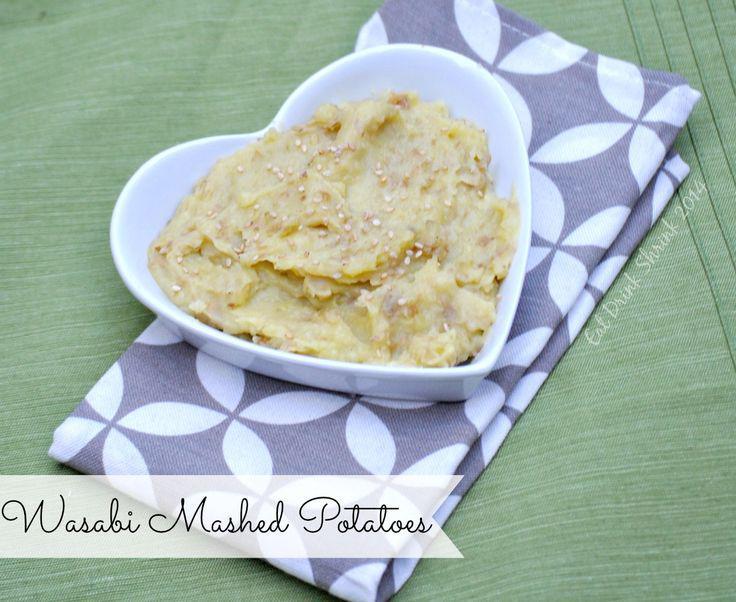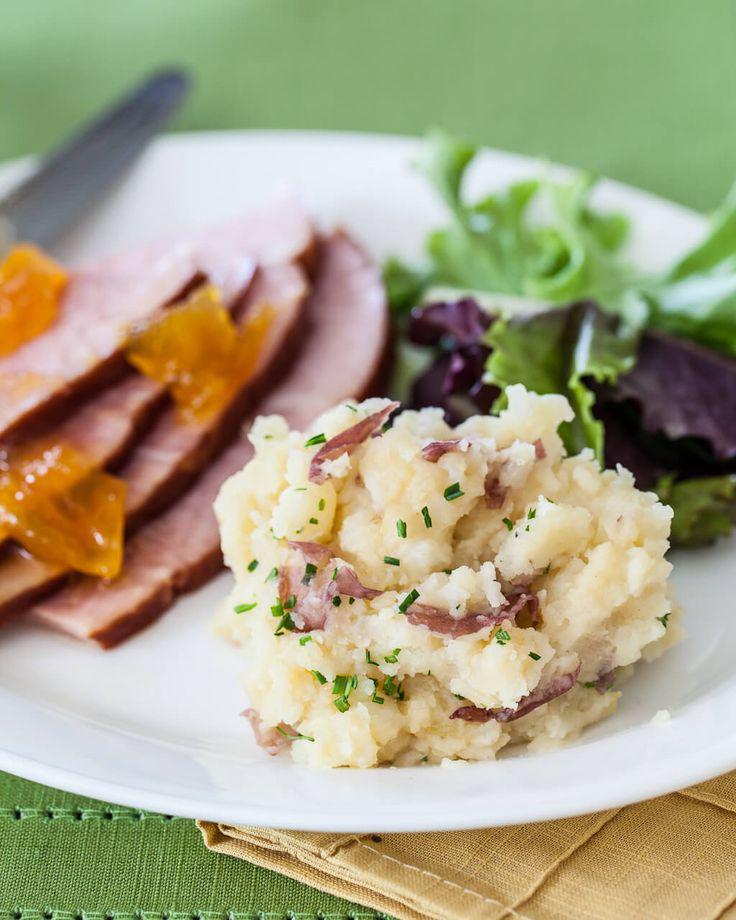The first image is the image on the left, the second image is the image on the right. Analyze the images presented: Is the assertion "Right image shows a round solid-colored dish containing some type of meat item." valid? Answer yes or no. Yes. The first image is the image on the left, the second image is the image on the right. For the images shown, is this caption "A spoon sits by the food in one of the images." true? Answer yes or no. No. 